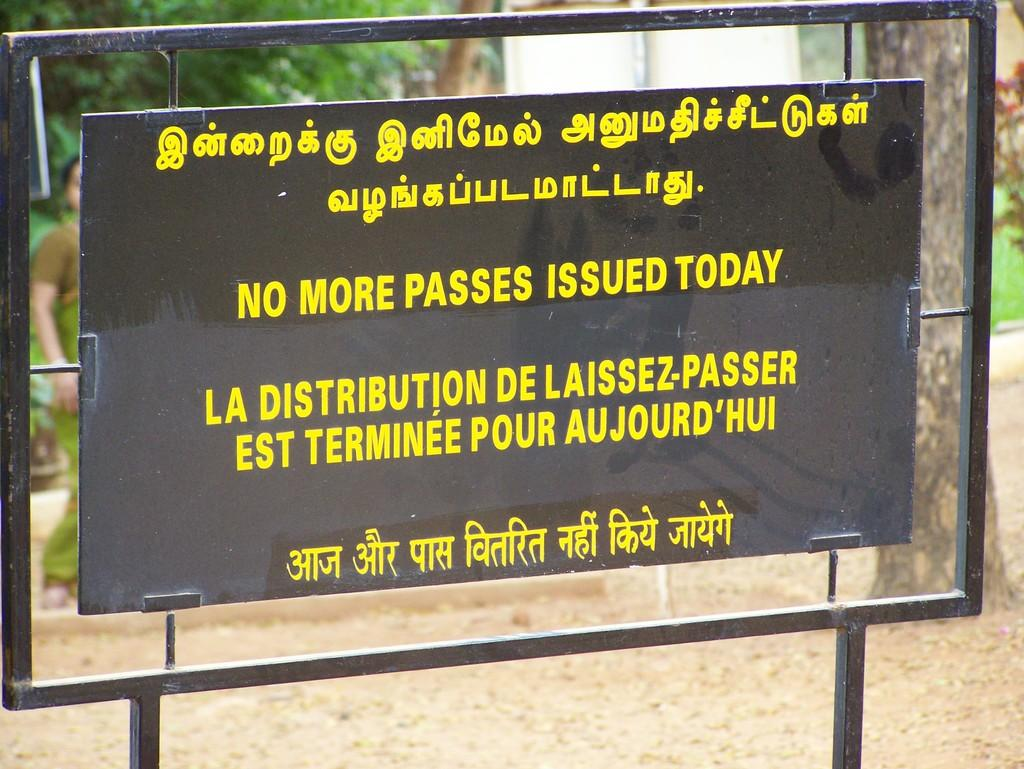Provide a one-sentence caption for the provided image. A sign informs that no more passes will be issued today. 